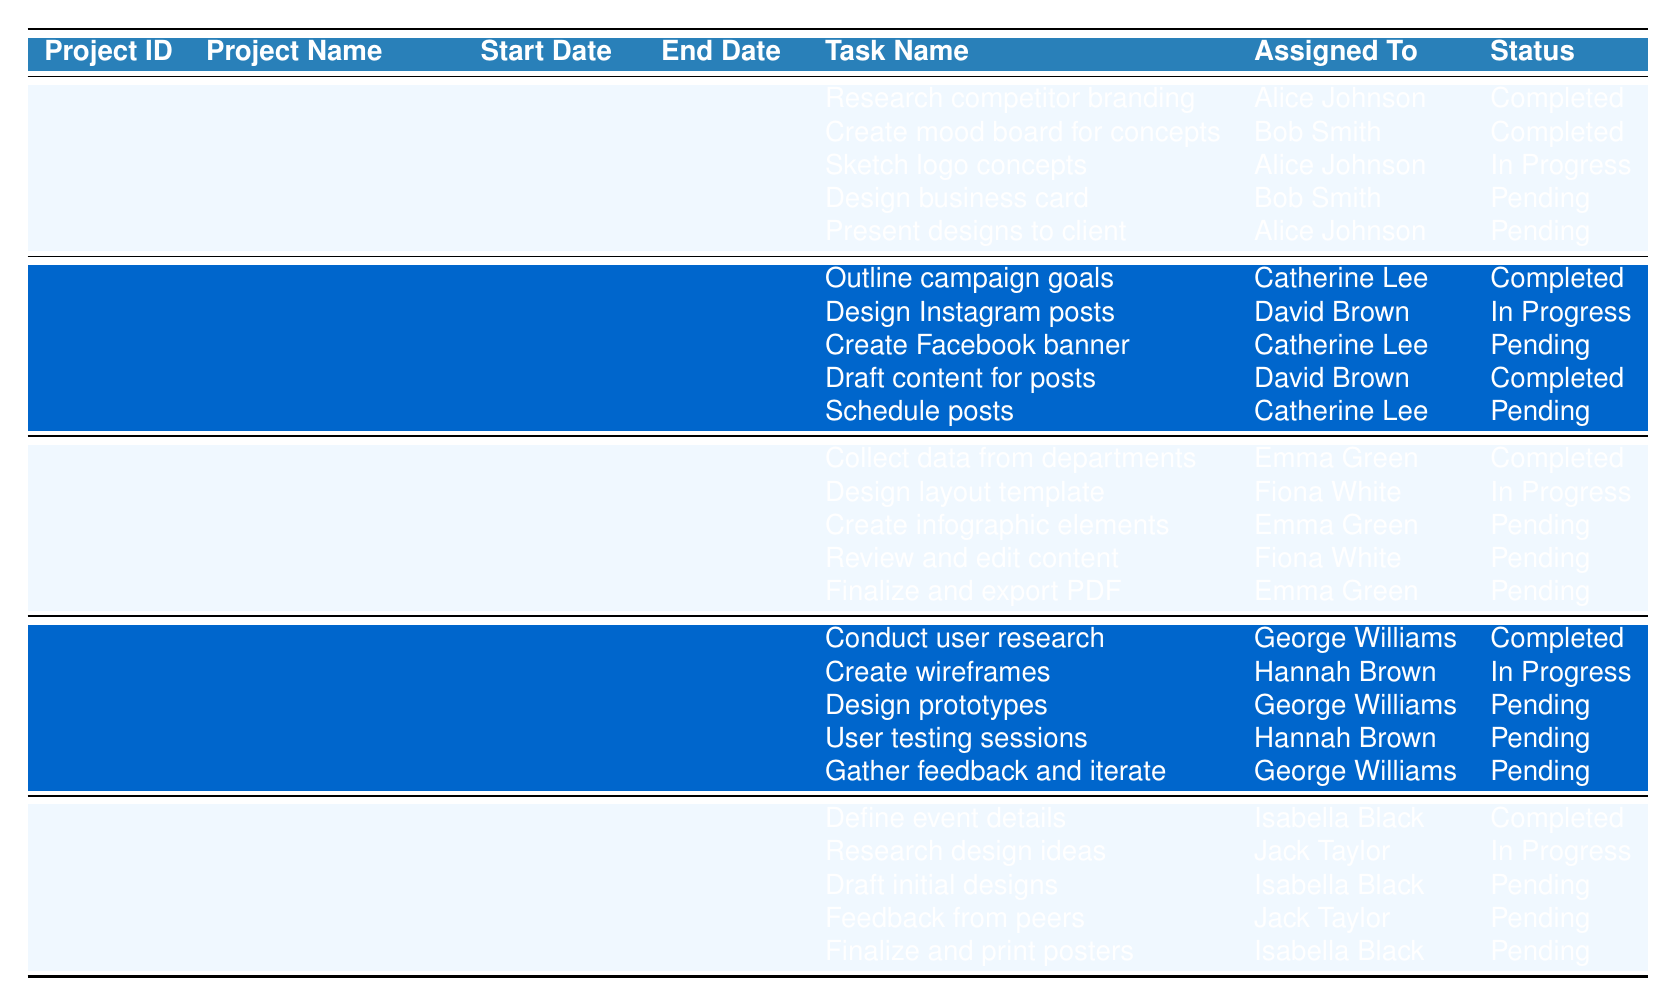What is the project name for Project ID 3? The table lists projects by their IDs and names. Looking at row 3, the project name for Project ID 3 is "Annual Report Design."
Answer: Annual Report Design Who is assigned to sketch logo concepts in the Brand Identity Redesign project? In the Brand Identity Redesign project, the task to sketch logo concepts is assigned to "Alice Johnson," as indicated in the respective row.
Answer: Alice Johnson How many tasks are pending for the Website UI/UX Design project? The Website UI/UX Design project has five tasks. Reviewing their statuses, three tasks are marked as pending.
Answer: 3 Is the task "Draft initial designs" completed for the Poster Design for Campus Event? The table indicates that the status for "Draft initial designs" in the Poster Design for Campus Event project is "pending." Therefore, it is not completed.
Answer: No Which project has the status "in progress" for the most tasks? By examining the table, the Social Media Campaign has one task (Design Instagram posts) in progress, while multiple projects have one: Brand Identity Redesign and Website UI/UX Design. However, the other three projects have multiple tasks pending. All projects are tied with one in progress, making none leading.
Answer: No project has the most in progress tasks What is the end date for the Social Media Campaign? The Social Media Campaign project has its end date listed as "2023-09-30" in the corresponding row of the table.
Answer: 2023-09-30 Which task in the Annual Report Design project is assigned to Fiona White? The task assigned to Fiona White in the Annual Report Design project is "Design layout template," as indicated in the table.
Answer: Design layout template How many total completed tasks are there in the table? Counting the completed tasks listed across all projects, there are 6 completed tasks in total: 3 from Brand Identity Redesign, 2 from Social Media Campaign, and 1 from Annual Report Design.
Answer: 6 Who is responsible for creating wireframes in the Website UI/UX Design project? The task of creating wireframes is assigned to "Hannah Brown," as identified in the respective row for the Website UI/UX Design project.
Answer: Hannah Brown Are there any tasks in the Brand Identity Redesign project that are completed? Yes, there are tasks in the Brand Identity Redesign project with the status "completed," specifically for tasks "Research competitor branding" and "Create mood board for concepts."
Answer: Yes What is the start date for the Poster Design for Campus Event project? The start date for the Poster Design for Campus Event project is stated as "2023-11-02" in the table.
Answer: 2023-11-02 